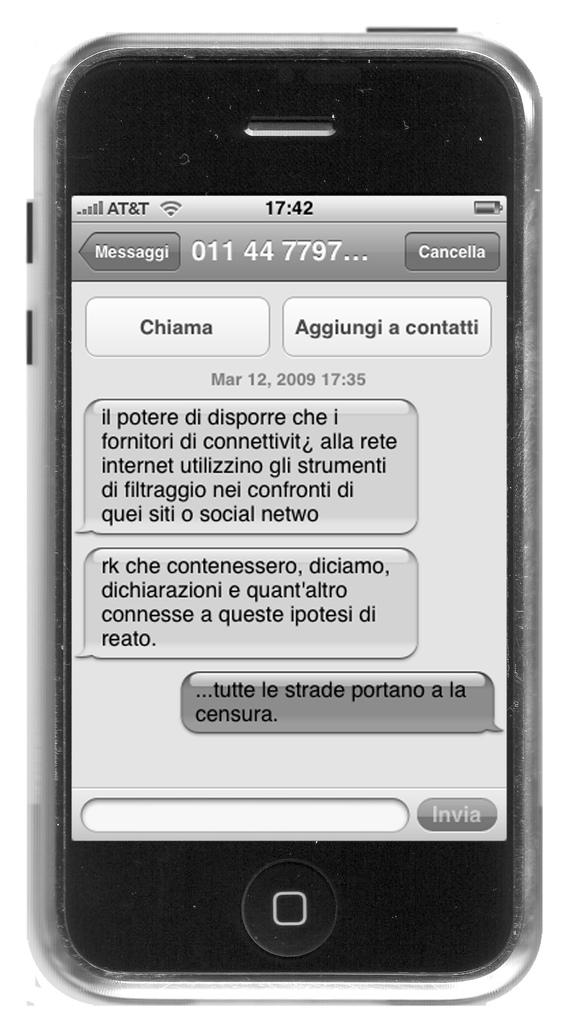<image>
Provide a brief description of the given image. a SMS display on a cell phone with words like Chiama on it 